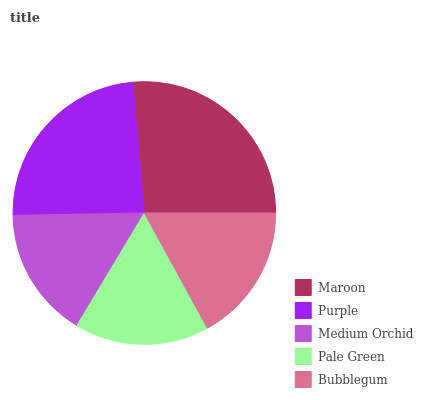Is Medium Orchid the minimum?
Answer yes or no. Yes. Is Maroon the maximum?
Answer yes or no. Yes. Is Purple the minimum?
Answer yes or no. No. Is Purple the maximum?
Answer yes or no. No. Is Maroon greater than Purple?
Answer yes or no. Yes. Is Purple less than Maroon?
Answer yes or no. Yes. Is Purple greater than Maroon?
Answer yes or no. No. Is Maroon less than Purple?
Answer yes or no. No. Is Bubblegum the high median?
Answer yes or no. Yes. Is Bubblegum the low median?
Answer yes or no. Yes. Is Purple the high median?
Answer yes or no. No. Is Purple the low median?
Answer yes or no. No. 